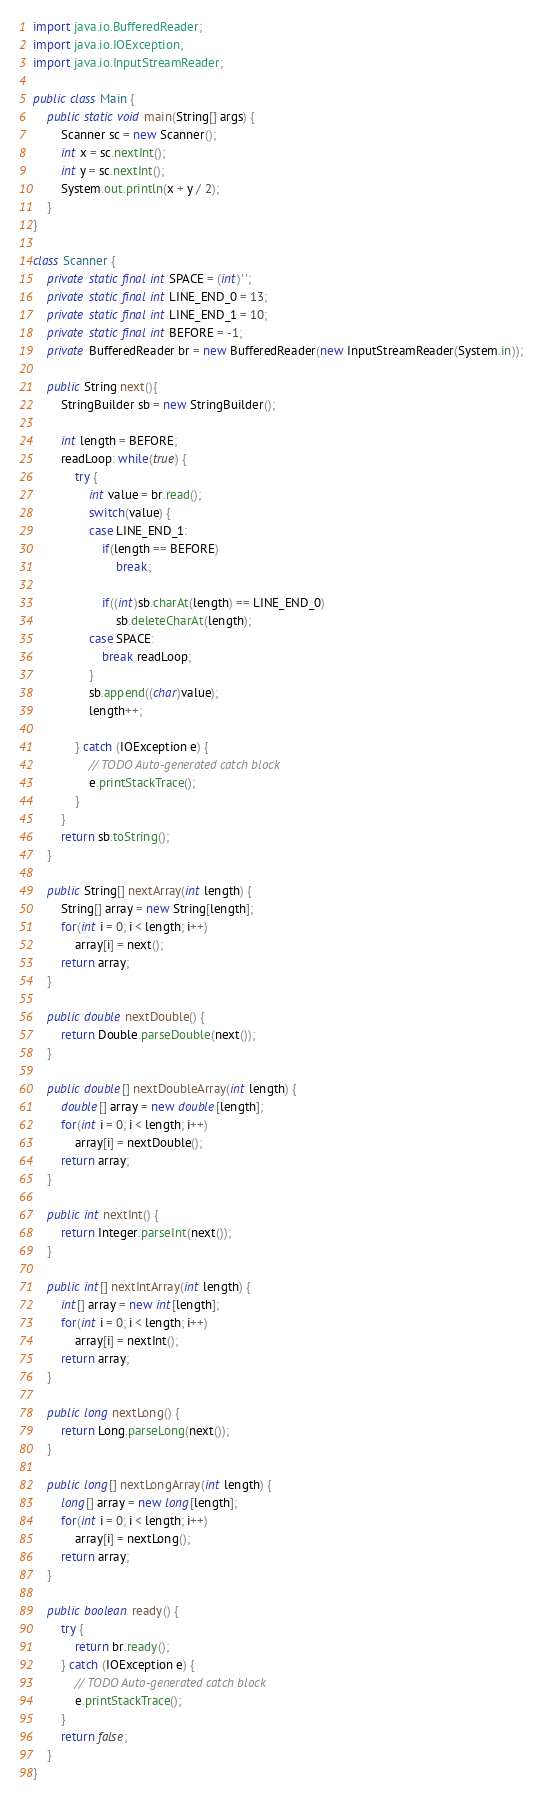<code> <loc_0><loc_0><loc_500><loc_500><_Java_>
import java.io.BufferedReader;
import java.io.IOException;
import java.io.InputStreamReader;

public class Main {
	public static void main(String[] args) {
		Scanner sc = new Scanner();
		int x = sc.nextInt();
		int y = sc.nextInt();
		System.out.println(x + y / 2);
	}
}

class Scanner {
	private static final int SPACE = (int)' ';
	private static final int LINE_END_0 = 13;
	private static final int LINE_END_1 = 10;
	private static final int BEFORE = -1;
	private BufferedReader br = new BufferedReader(new InputStreamReader(System.in));
	
	public String next(){
		StringBuilder sb = new StringBuilder();
		
		int length = BEFORE;
		readLoop: while(true) {
			try {
				int value = br.read();
				switch(value) {
				case LINE_END_1:
					if(length == BEFORE)
						break;
					
					if((int)sb.charAt(length) == LINE_END_0)
						sb.deleteCharAt(length);
				case SPACE:
					break readLoop;
				}
				sb.append((char)value);
				length++;

			} catch (IOException e) {
				// TODO Auto-generated catch block
				e.printStackTrace();
			}
		}
		return sb.toString();
	}
	
	public String[] nextArray(int length) {
		String[] array = new String[length];
		for(int i = 0; i < length; i++)
			array[i] = next();
		return array;
	}
	
	public double nextDouble() {
		return Double.parseDouble(next());
	}
	
	public double[] nextDoubleArray(int length) {
		double[] array = new double[length];
		for(int i = 0; i < length; i++)
			array[i] = nextDouble();
		return array;
	}
	
	public int nextInt() {
		return Integer.parseInt(next());
	}
	
	public int[] nextIntArray(int length) {
		int[] array = new int[length];
		for(int i = 0; i < length; i++)
			array[i] = nextInt();
		return array;
	}
	
	public long nextLong() {
		return Long.parseLong(next());
	}
	
	public long[] nextLongArray(int length) {
		long[] array = new long[length];
		for(int i = 0; i < length; i++)
			array[i] = nextLong();
		return array;
	}
	
	public boolean ready() {
		try {
			return br.ready();
		} catch (IOException e) {
			// TODO Auto-generated catch block
			e.printStackTrace();
		}
		return false;
	}
}
</code> 